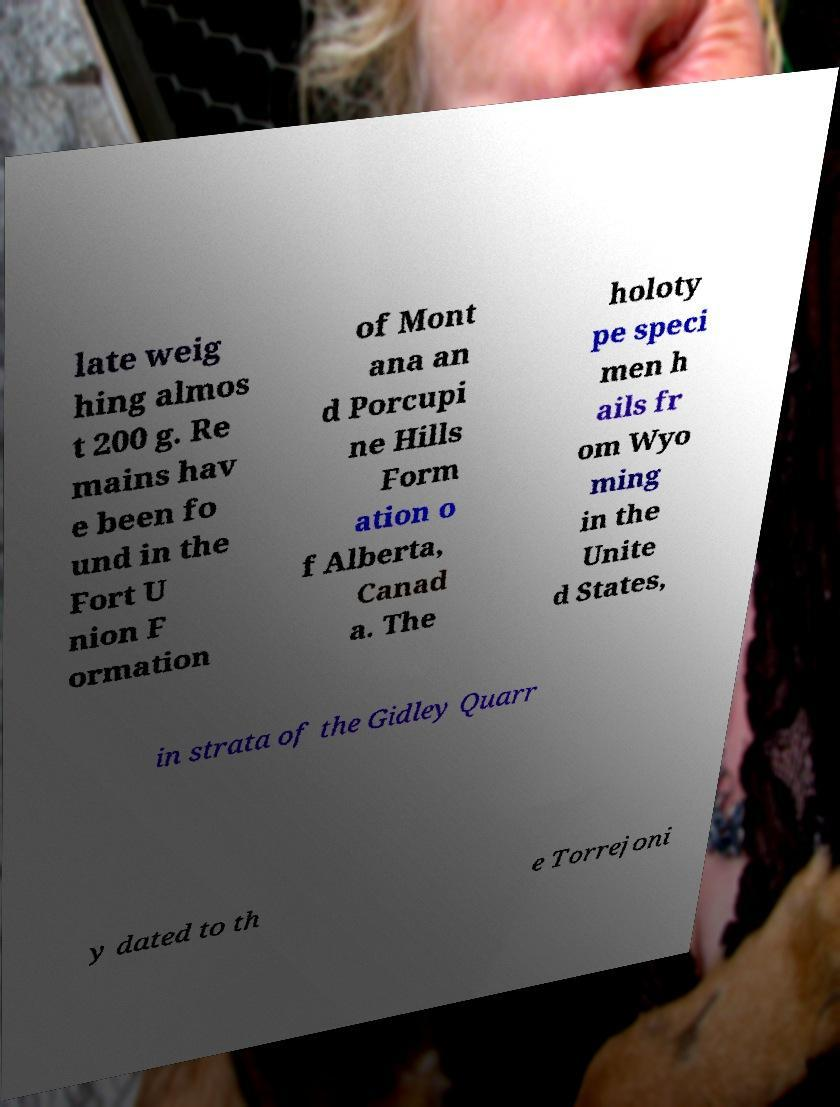I need the written content from this picture converted into text. Can you do that? late weig hing almos t 200 g. Re mains hav e been fo und in the Fort U nion F ormation of Mont ana an d Porcupi ne Hills Form ation o f Alberta, Canad a. The holoty pe speci men h ails fr om Wyo ming in the Unite d States, in strata of the Gidley Quarr y dated to th e Torrejoni 